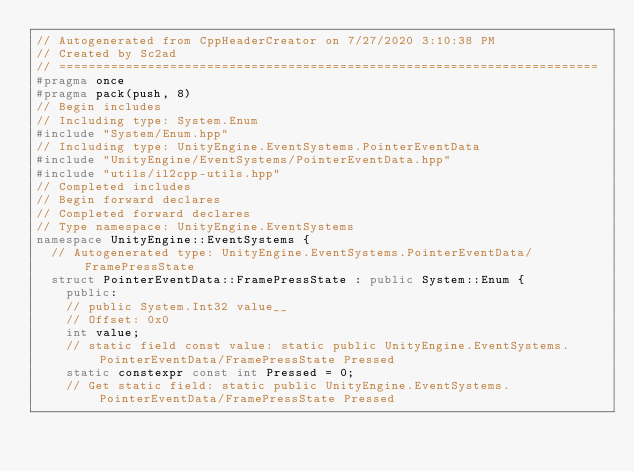<code> <loc_0><loc_0><loc_500><loc_500><_C++_>// Autogenerated from CppHeaderCreator on 7/27/2020 3:10:38 PM
// Created by Sc2ad
// =========================================================================
#pragma once
#pragma pack(push, 8)
// Begin includes
// Including type: System.Enum
#include "System/Enum.hpp"
// Including type: UnityEngine.EventSystems.PointerEventData
#include "UnityEngine/EventSystems/PointerEventData.hpp"
#include "utils/il2cpp-utils.hpp"
// Completed includes
// Begin forward declares
// Completed forward declares
// Type namespace: UnityEngine.EventSystems
namespace UnityEngine::EventSystems {
  // Autogenerated type: UnityEngine.EventSystems.PointerEventData/FramePressState
  struct PointerEventData::FramePressState : public System::Enum {
    public:
    // public System.Int32 value__
    // Offset: 0x0
    int value;
    // static field const value: static public UnityEngine.EventSystems.PointerEventData/FramePressState Pressed
    static constexpr const int Pressed = 0;
    // Get static field: static public UnityEngine.EventSystems.PointerEventData/FramePressState Pressed</code> 